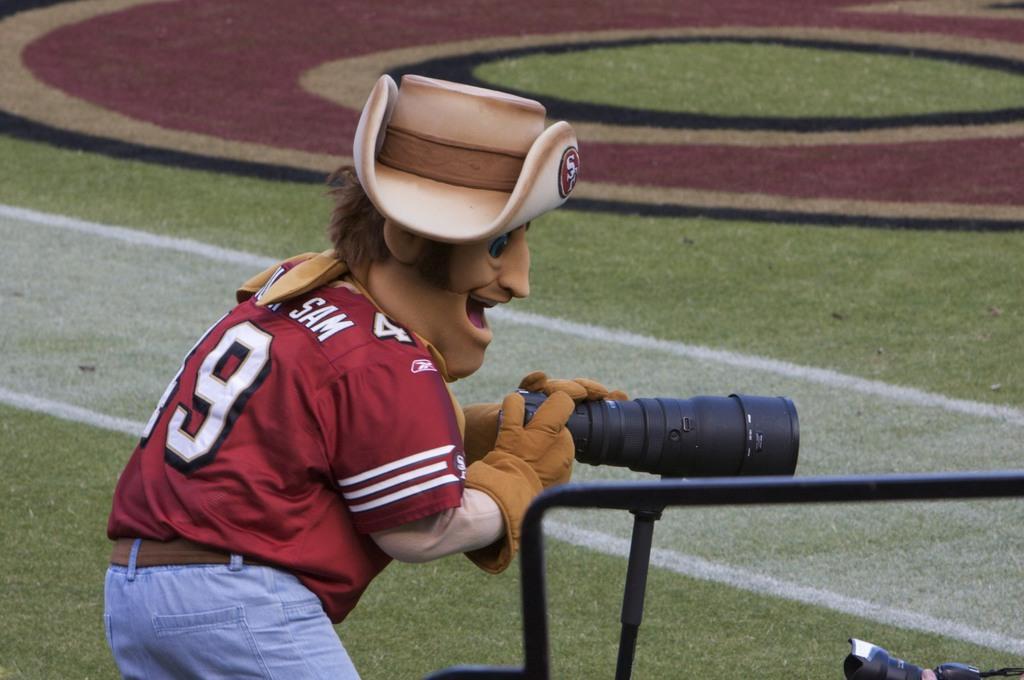Describe this image in one or two sentences. In this image there is one person who is wearing a hat and some costumes and he is holding a camera, at the bottom there is grass and there are some sticks. 